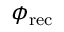<formula> <loc_0><loc_0><loc_500><loc_500>\phi _ { r e c }</formula> 